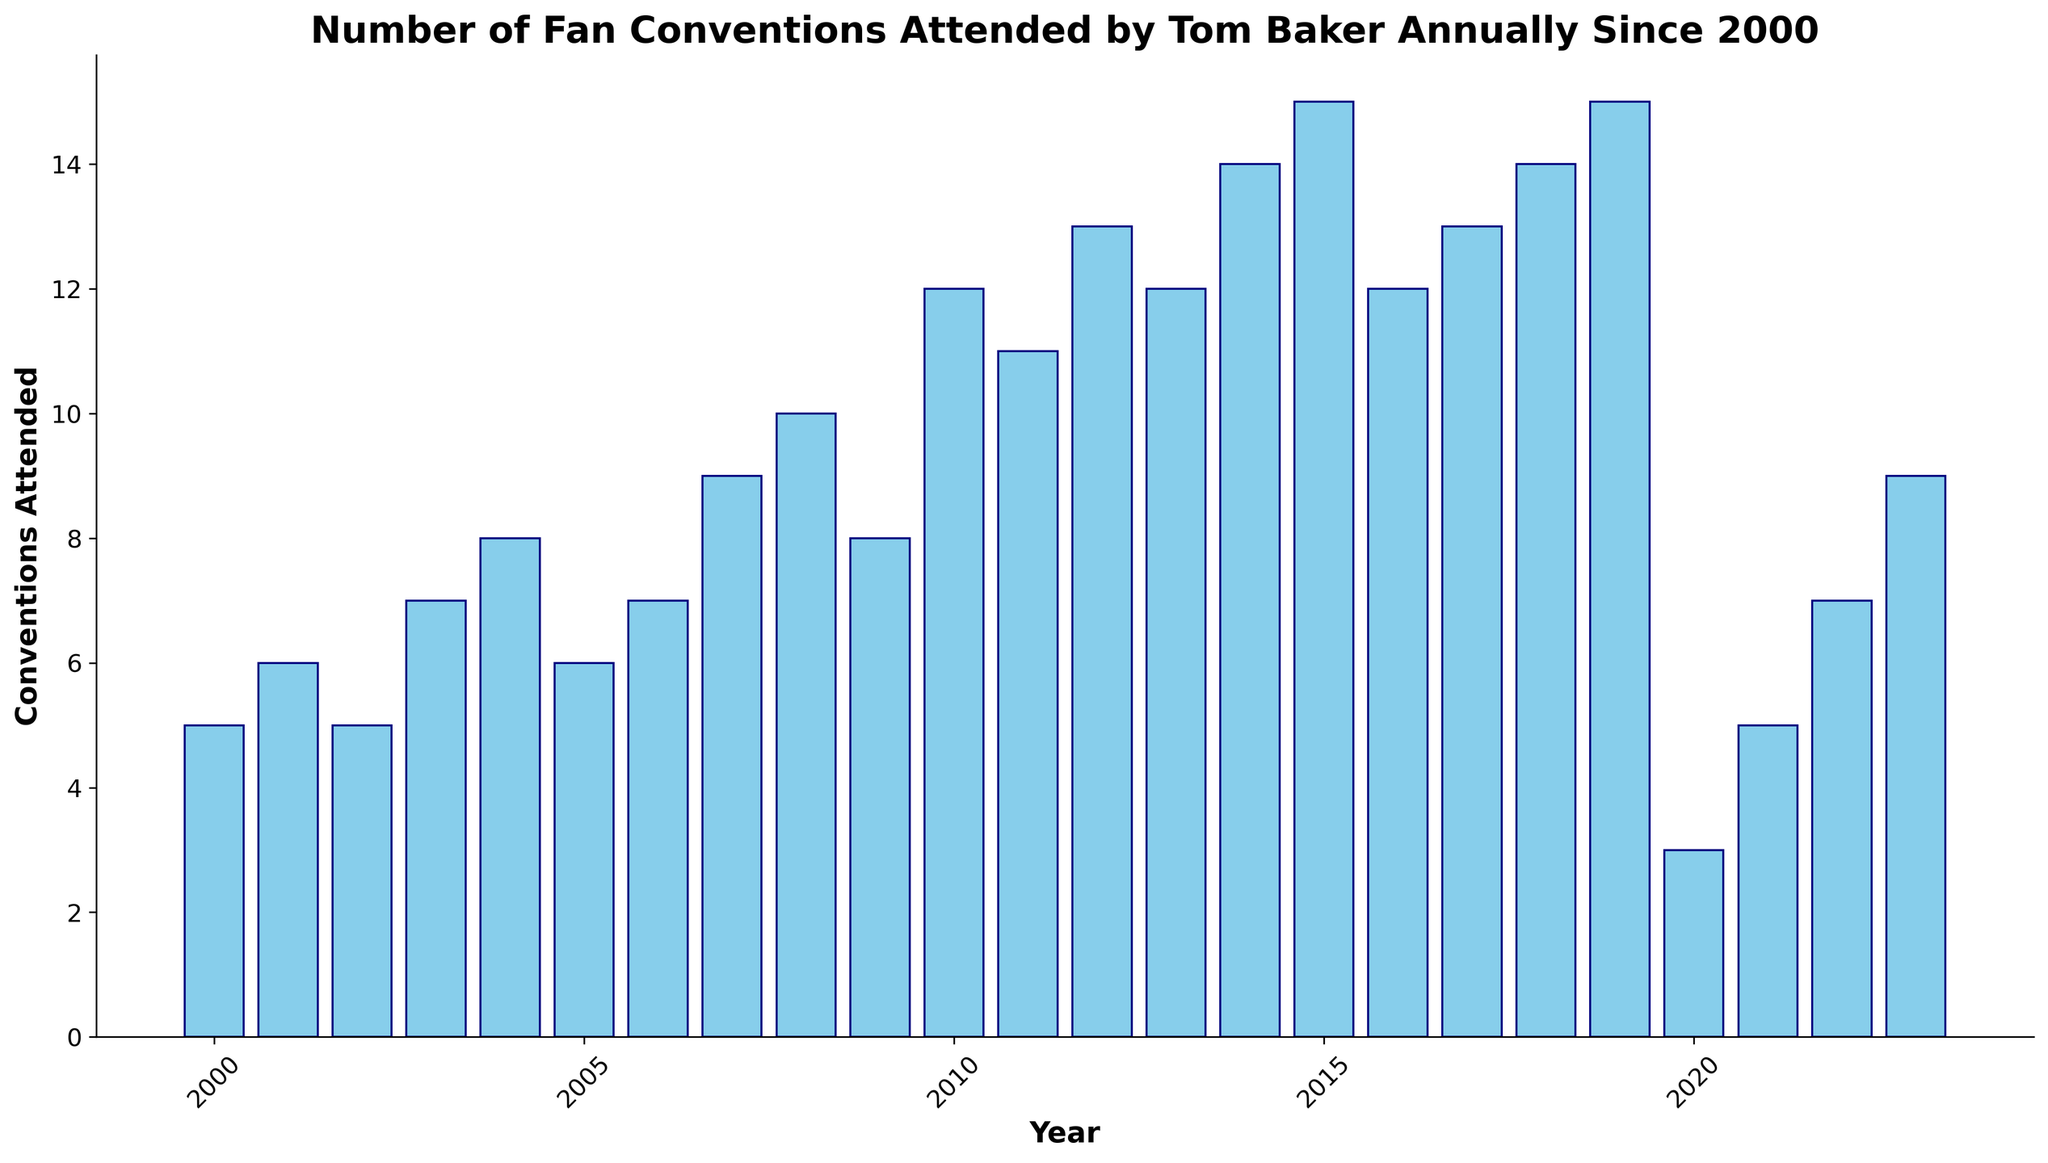What is the highest number of conventions Tom Baker attended in a single year? The tallest bar in the bar chart corresponds to the highest number of conventions. The year 2019 has the tallest bar, indicating 15 conventions attended.
Answer: 15 Which year had the lowest number of conventions attended by Tom Baker? The shortest bar represents the lowest number of conventions. The year 2020 has the shortest bar at 3 conventions attended.
Answer: 2020 How many conventions in total did Tom Baker attend from 2010 to 2013? Sum the conventions attended from 2010 (12), 2011 (11), 2012 (13), and 2013 (12). The sum is 12 + 11 + 13 + 12 = 48.
Answer: 48 During which year did Tom Baker experience the most significant increase in conventions attended compared to the previous year? Calculate the difference in conventions attended year-over-year and find the maximum increase. From 2009 to 2010, the conventions increased from 8 to 12, a difference of 4. This is the largest increase.
Answer: 2010 How many years did Tom Baker attend more than 10 conventions? Identify the bars with heights greater than 10 conventions. The years 2010, 2011, 2012, 2013, 2014, 2015, 2016, 2017, 2018, and 2019 meet this criterion, totaling 10 years.
Answer: 10 Compared to 2020, how many more conventions did Tom Baker attend in 2023? The difference between conventions in 2023 (9) and 2020 (3) is 9 - 3 = 6.
Answer: 6 In which years did Tom Baker attend exactly 12 conventions? Observe that two bars are marked at 12 conventions for the years 2010 and 2013.
Answer: 2010 and 2013 How many years did Tom Baker attend fewer conventions than the average annual conventions since 2000? Calculate the average: sum all conventions and divide by the number of years, i.e., (sum = 224, years = 24, avg = 224/24 = 9.33). Count the years with conventions fewer than 9.33, which are: 2000, 2001, 2002, 2005, 2020, and 2021—totaling 6 years.
Answer: 6 What is the average number of conventions Tom Baker attended annually from 2000 to 2009? Sum the conventions from 2000 to 2009: 5 + 6 + 5 + 7 + 8 + 6 + 7 + 9 + 10 + 8 = 71. The average is 71 / 10 = 7.1.
Answer: 7.1 